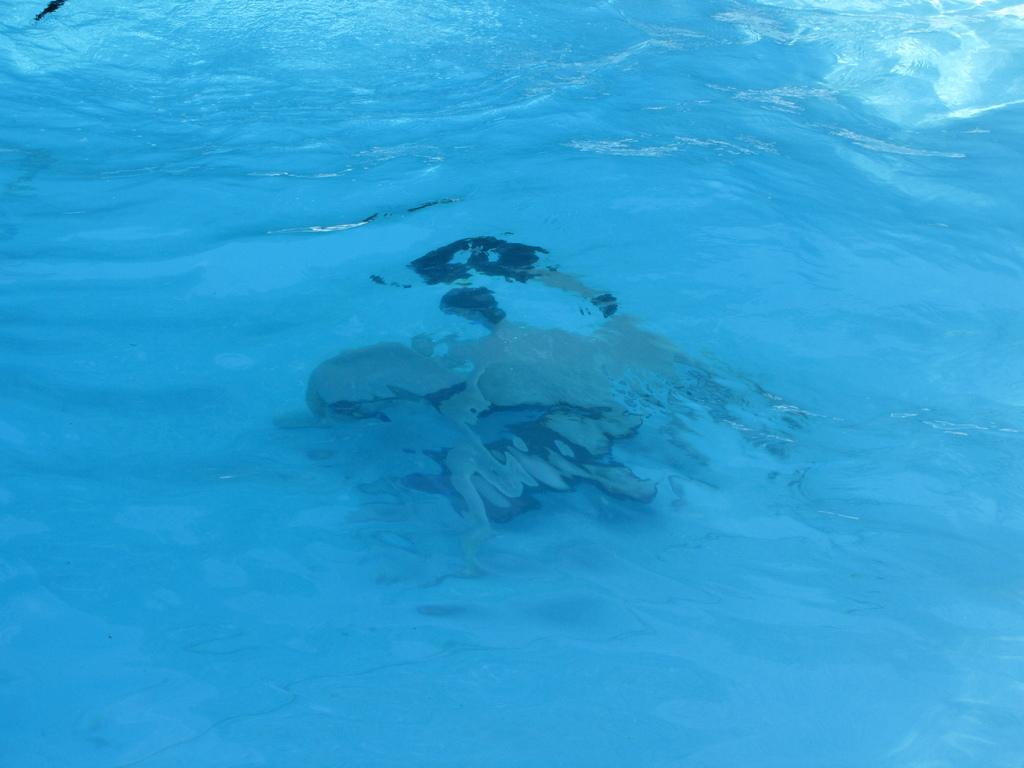What is present in the image? There is water visible in the image. What is the person in the image doing? There is a person swimming in the water. What type of beetle can be seen crawling on the texture of the dime in the image? There is no beetle or dime present in the image; it only features water and a person swimming. 